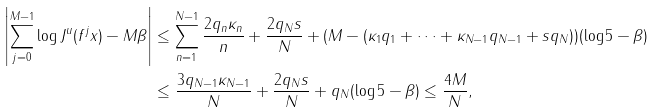<formula> <loc_0><loc_0><loc_500><loc_500>\left | \sum _ { j = 0 } ^ { M - 1 } \log J ^ { u } ( f ^ { j } x ) - M \beta \right | & \leq \sum _ { n = 1 } ^ { N - 1 } \frac { 2 q _ { n } \kappa _ { n } } { n } + \frac { 2 q _ { N } s } { N } + ( M - ( \kappa _ { 1 } q _ { 1 } + \cdots + \kappa _ { N - 1 } q _ { N - 1 } + s q _ { N } ) ) ( \log 5 - \beta ) \\ & \leq \frac { 3 q _ { N - 1 } \kappa _ { N - 1 } } { N } + \frac { 2 q _ { N } s } { N } + q _ { N } ( \log 5 - \beta ) \leq \frac { 4 M } { N } ,</formula> 